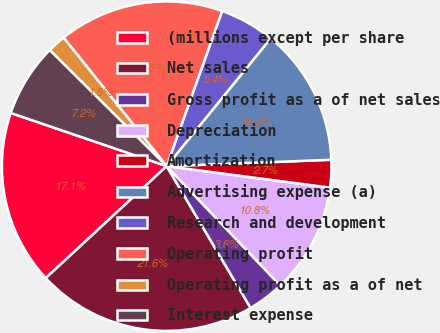Convert chart. <chart><loc_0><loc_0><loc_500><loc_500><pie_chart><fcel>(millions except per share<fcel>Net sales<fcel>Gross profit as a of net sales<fcel>Depreciation<fcel>Amortization<fcel>Advertising expense (a)<fcel>Research and development<fcel>Operating profit<fcel>Operating profit as a of net<fcel>Interest expense<nl><fcel>17.12%<fcel>21.62%<fcel>3.6%<fcel>10.81%<fcel>2.7%<fcel>13.51%<fcel>5.41%<fcel>16.22%<fcel>1.8%<fcel>7.21%<nl></chart> 